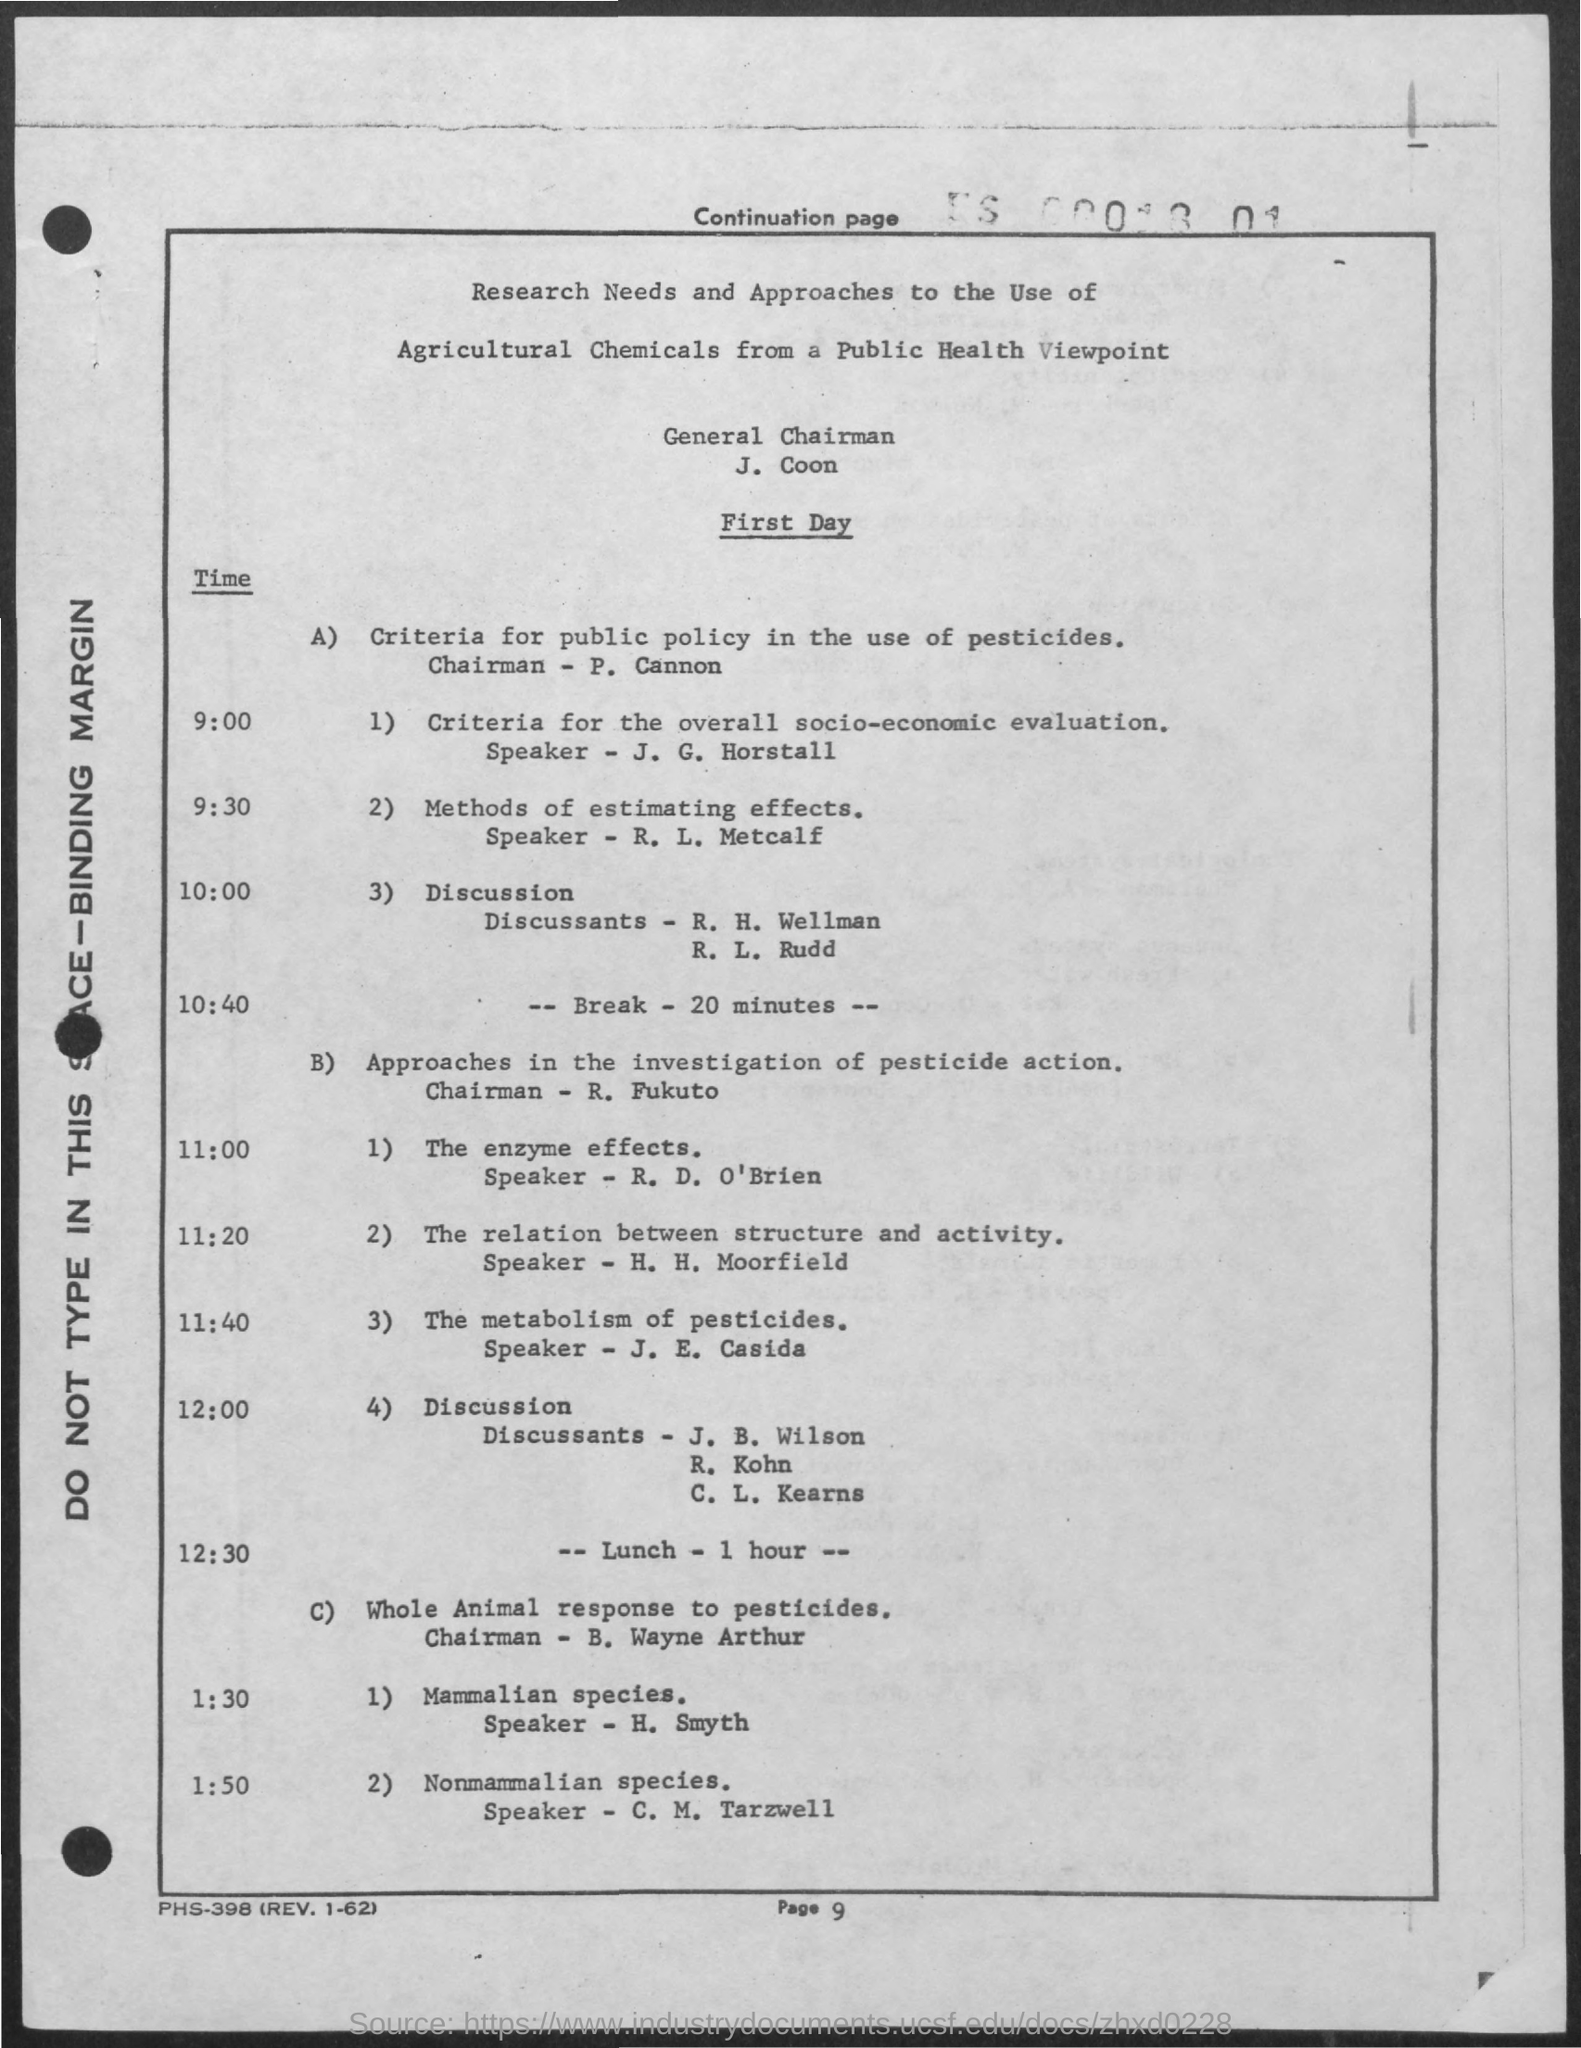Who is the General Chairman?
Offer a terse response. J. Coon. What is the page number?
Offer a very short reply. 9. Who is the speaker of "The metabolism of pesticides" ?
Keep it short and to the point. J. E. Casida. 